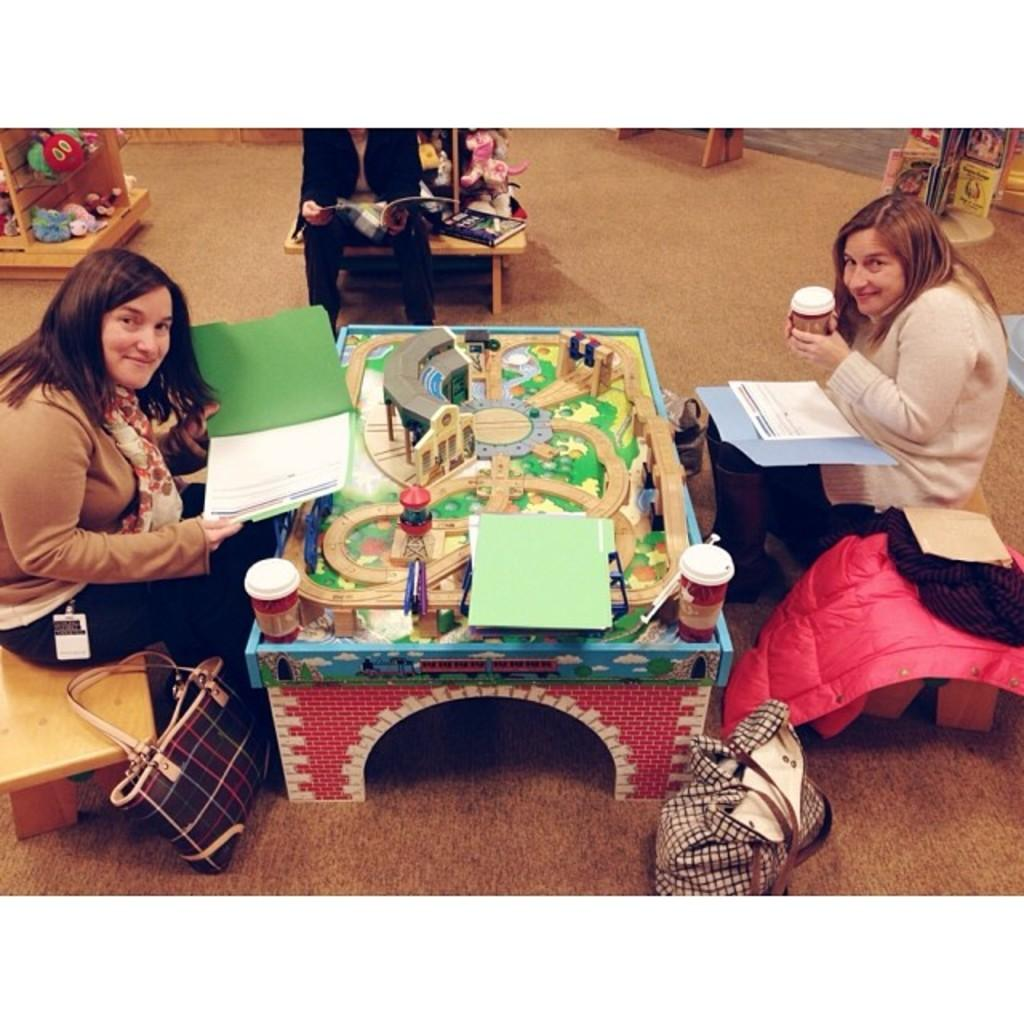How many people are sitting on the bench in the image? There are three people sitting on a bench in the image. What can be seen in addition to the people on the bench? There is a miniature object and a cup in the image. What is on the floor near the bench? There is a bag on the floor in the image. What type of dress is the cap wearing in the image? There is no cap or dress present in the image. 